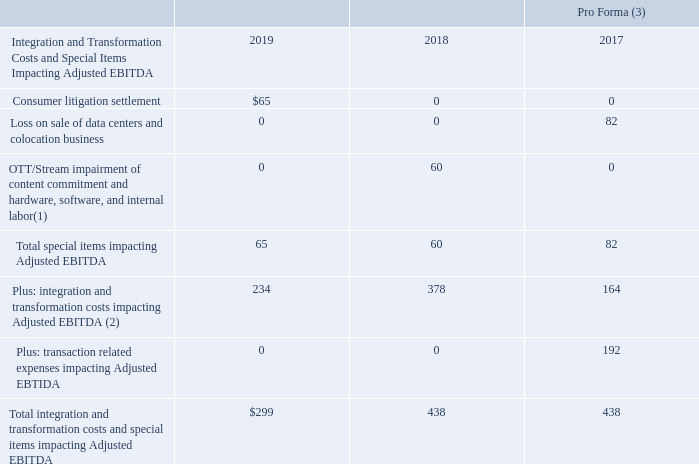Non-GAAP Integration and Transformation Costs and Special Items
(UNAUDITED)
($ in millions)
(1) Includes $18 million of hardware impairment for Q3 2018 and $15 million of content commitment impairment and $27 million of hardware, software and internal labor impairment in Q1 2018.
(2) Includes $55 million of restructuring reserve impairment for Q2 2018.
(3) Reference to pro forma figures assume the Level 3 acquisition and the colocation and data center sale took place on January 1, 2017.
What does the OTT/Stream impairment of content commitment and hardware, software, and internal labor costs in 2018 include? $18 million of hardware impairment for q3 2018 and $15 million of content commitment impairment and $27 million of hardware, software and internal labor impairment in q1 2018. What does the integration and transformation costs impacting Adjusted EBITDA include? $55 million of restructuring reserve impairment for q2 2018. What does the reference to pro forma figures assume? The level 3 acquisition and the colocation and data center sale took place on january 1, 2017. How many cost components are included in the OTT/Stream impairment of content commitment and hardware, software, and internal labor costs in 2018? Hardware impairment##content commitment impairment##hardware, software and internal labor impairment
answer: 3. What is the change in total special items impacting adjusted EBITDA between 2018 and 2019?
Answer scale should be: million. $65-$60
Answer: 5. What is the percentage change in total special items impacting adjusted EBITDA between 2018 and 2019?
Answer scale should be: percent. ($65-$60)/$60
Answer: 8.33. 